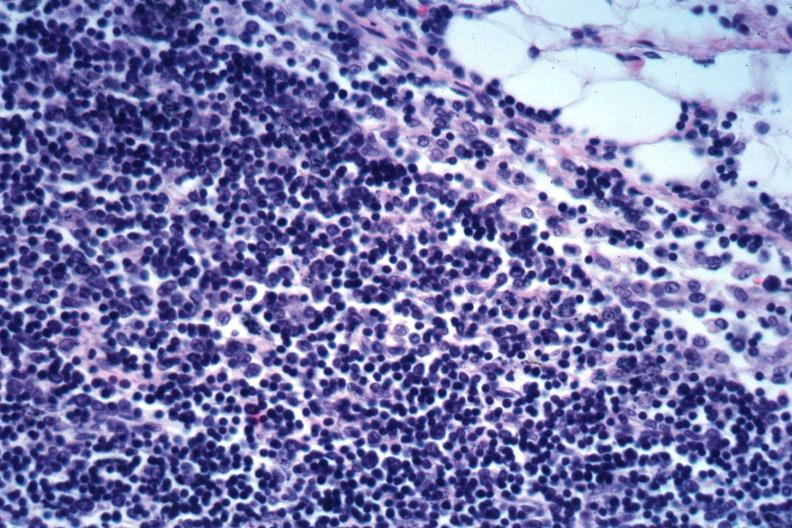does this image show edge of node with infiltration of capsule obliteration of subcapsular sinus mixture of small dark lymphocytes and larger cells with vesicular nuclei not specified?
Answer the question using a single word or phrase. Yes 